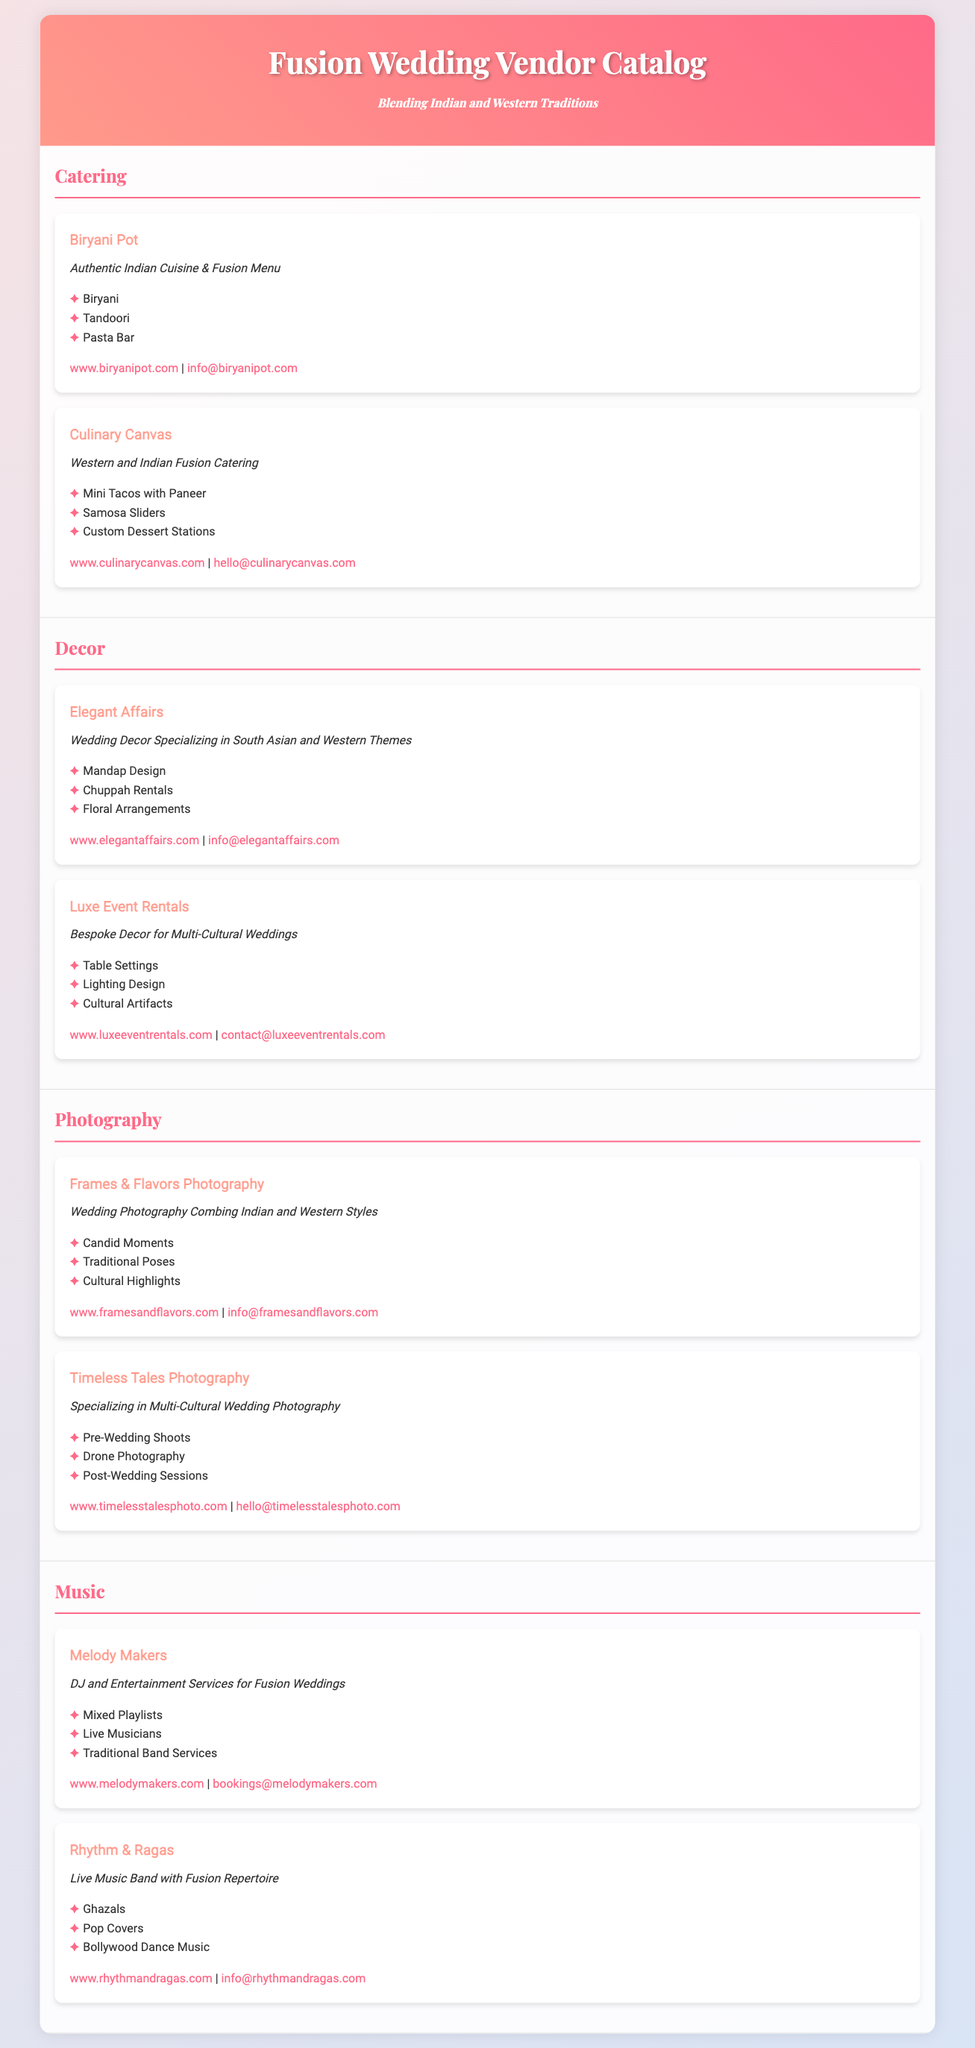What is the name of the catering vendor that specializes in Indian cuisine? The vendor that specializes in Indian cuisine is named "Biryani Pot."
Answer: Biryani Pot How many vendors are listed for photography? There are two vendors listed under the photography section.
Answer: 2 What type of services does "Culinary Canvas" provide? "Culinary Canvas" provides Western and Indian Fusion Catering services.
Answer: Western and Indian Fusion Catering Which vendor offers live music band services? The vendor that offers live music band services is "Rhythm & Ragas."
Answer: Rhythm & Ragas What are the specialties of "Elegant Affairs"? "Elegant Affairs" specializes in Mandap Design, Chuppah Rentals, and Floral Arrangements.
Answer: Mandap Design, Chuppah Rentals, Floral Arrangements Which vendor provides a pasta bar in their catering? The vendor that provides a pasta bar is "Biryani Pot."
Answer: Biryani Pot What is the contact email for "Melody Makers"? The contact email for "Melody Makers" is bookings@melodymakers.com.
Answer: bookings@melodymakers.com What unique service does "Timeless Tales Photography" offer? "Timeless Tales Photography" offers drone photography as a unique service.
Answer: Drone Photography Which decor vendor specializes in floral arrangements? "Elegant Affairs" specializes in floral arrangements.
Answer: Elegant Affairs 